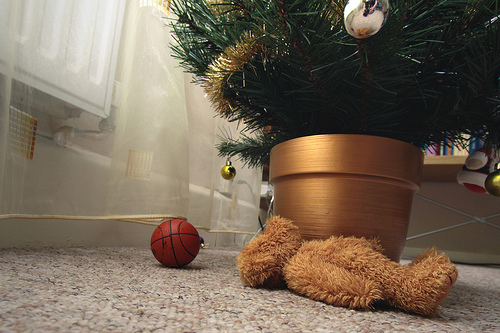<image>
Is there a teddy bear under the floor? No. The teddy bear is not positioned under the floor. The vertical relationship between these objects is different. Is the doll in front of the ball? No. The doll is not in front of the ball. The spatial positioning shows a different relationship between these objects. 